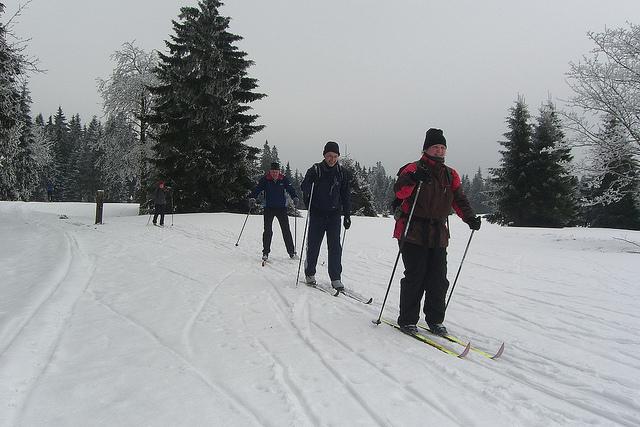How many ski poles are stuck into the snow?
Answer briefly. 8. What color is the jacket of the man closest?
Be succinct. Red and brown. Is it a sunny day?
Be succinct. No. Are the people in a single file line or side by side?
Quick response, please. Single file. What sport are they playing?
Write a very short answer. Skiing. What is the man doing in this photo?
Concise answer only. Skiing. What are in their hands?
Quick response, please. Ski poles. What is the color of the sky?
Answer briefly. Gray. Is it snowing in this picture?
Short answer required. No. What color cap is the person wearing?
Give a very brief answer. Black. Did this person fall down?
Give a very brief answer. No. What color are the skis?
Write a very short answer. Yellow. How many skis are there?
Give a very brief answer. 8. 